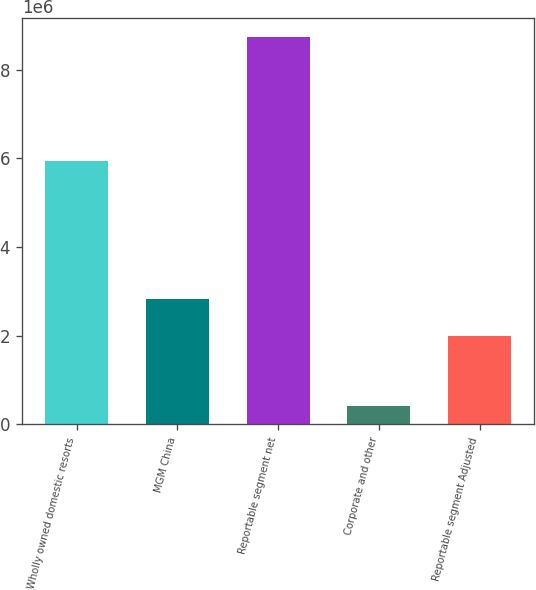<chart> <loc_0><loc_0><loc_500><loc_500><bar_chart><fcel>Wholly owned domestic resorts<fcel>MGM China<fcel>Reportable segment net<fcel>Corporate and other<fcel>Reportable segment Adjusted<nl><fcel>5.93279e+06<fcel>2.83657e+06<fcel>8.74047e+06<fcel>420377<fcel>2.00456e+06<nl></chart> 